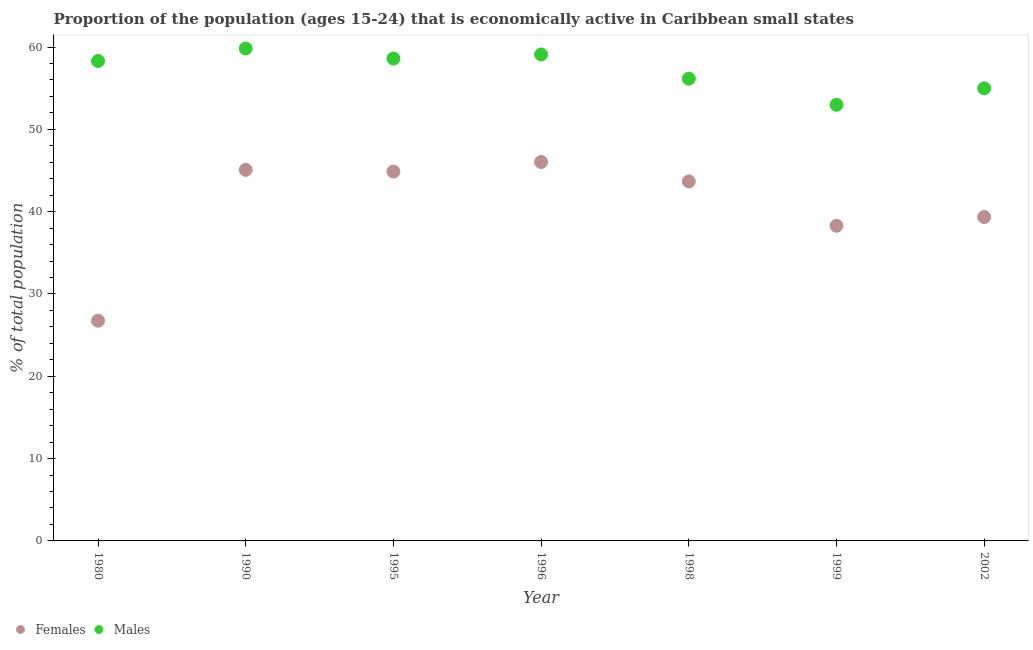What is the percentage of economically active female population in 2002?
Make the answer very short. 39.35. Across all years, what is the maximum percentage of economically active female population?
Offer a very short reply. 46.04. Across all years, what is the minimum percentage of economically active male population?
Give a very brief answer. 52.98. In which year was the percentage of economically active female population minimum?
Give a very brief answer. 1980. What is the total percentage of economically active male population in the graph?
Your response must be concise. 399.94. What is the difference between the percentage of economically active male population in 1980 and that in 1990?
Your answer should be compact. -1.52. What is the difference between the percentage of economically active male population in 2002 and the percentage of economically active female population in 1995?
Provide a short and direct response. 10.11. What is the average percentage of economically active female population per year?
Your answer should be very brief. 40.58. In the year 1998, what is the difference between the percentage of economically active male population and percentage of economically active female population?
Ensure brevity in your answer.  12.48. What is the ratio of the percentage of economically active female population in 1999 to that in 2002?
Provide a short and direct response. 0.97. Is the difference between the percentage of economically active male population in 1995 and 1998 greater than the difference between the percentage of economically active female population in 1995 and 1998?
Provide a succinct answer. Yes. What is the difference between the highest and the second highest percentage of economically active female population?
Your response must be concise. 0.96. What is the difference between the highest and the lowest percentage of economically active male population?
Ensure brevity in your answer.  6.84. Is the percentage of economically active male population strictly less than the percentage of economically active female population over the years?
Offer a very short reply. No. How many years are there in the graph?
Make the answer very short. 7. Are the values on the major ticks of Y-axis written in scientific E-notation?
Provide a short and direct response. No. Does the graph contain grids?
Give a very brief answer. No. What is the title of the graph?
Give a very brief answer. Proportion of the population (ages 15-24) that is economically active in Caribbean small states. What is the label or title of the Y-axis?
Ensure brevity in your answer.  % of total population. What is the % of total population of Females in 1980?
Ensure brevity in your answer.  26.76. What is the % of total population in Males in 1980?
Your answer should be compact. 58.31. What is the % of total population of Females in 1990?
Your answer should be compact. 45.08. What is the % of total population in Males in 1990?
Your answer should be compact. 59.82. What is the % of total population in Females in 1995?
Offer a very short reply. 44.87. What is the % of total population in Males in 1995?
Make the answer very short. 58.6. What is the % of total population in Females in 1996?
Ensure brevity in your answer.  46.04. What is the % of total population in Males in 1996?
Make the answer very short. 59.1. What is the % of total population in Females in 1998?
Provide a short and direct response. 43.68. What is the % of total population in Males in 1998?
Offer a very short reply. 56.16. What is the % of total population in Females in 1999?
Your answer should be very brief. 38.28. What is the % of total population in Males in 1999?
Your response must be concise. 52.98. What is the % of total population in Females in 2002?
Give a very brief answer. 39.35. What is the % of total population of Males in 2002?
Provide a succinct answer. 54.98. Across all years, what is the maximum % of total population in Females?
Provide a short and direct response. 46.04. Across all years, what is the maximum % of total population of Males?
Ensure brevity in your answer.  59.82. Across all years, what is the minimum % of total population in Females?
Your answer should be compact. 26.76. Across all years, what is the minimum % of total population of Males?
Give a very brief answer. 52.98. What is the total % of total population in Females in the graph?
Provide a short and direct response. 284.05. What is the total % of total population of Males in the graph?
Give a very brief answer. 399.94. What is the difference between the % of total population of Females in 1980 and that in 1990?
Give a very brief answer. -18.32. What is the difference between the % of total population in Males in 1980 and that in 1990?
Keep it short and to the point. -1.52. What is the difference between the % of total population in Females in 1980 and that in 1995?
Your answer should be compact. -18.12. What is the difference between the % of total population in Males in 1980 and that in 1995?
Provide a succinct answer. -0.29. What is the difference between the % of total population of Females in 1980 and that in 1996?
Your answer should be compact. -19.28. What is the difference between the % of total population of Males in 1980 and that in 1996?
Offer a terse response. -0.79. What is the difference between the % of total population of Females in 1980 and that in 1998?
Your answer should be very brief. -16.92. What is the difference between the % of total population in Males in 1980 and that in 1998?
Offer a very short reply. 2.15. What is the difference between the % of total population of Females in 1980 and that in 1999?
Provide a succinct answer. -11.53. What is the difference between the % of total population in Males in 1980 and that in 1999?
Give a very brief answer. 5.33. What is the difference between the % of total population in Females in 1980 and that in 2002?
Your response must be concise. -12.59. What is the difference between the % of total population in Males in 1980 and that in 2002?
Keep it short and to the point. 3.32. What is the difference between the % of total population in Females in 1990 and that in 1995?
Your answer should be very brief. 0.21. What is the difference between the % of total population of Males in 1990 and that in 1995?
Keep it short and to the point. 1.22. What is the difference between the % of total population of Females in 1990 and that in 1996?
Your answer should be very brief. -0.96. What is the difference between the % of total population in Males in 1990 and that in 1996?
Offer a terse response. 0.72. What is the difference between the % of total population of Females in 1990 and that in 1998?
Ensure brevity in your answer.  1.4. What is the difference between the % of total population of Males in 1990 and that in 1998?
Keep it short and to the point. 3.67. What is the difference between the % of total population of Females in 1990 and that in 1999?
Provide a short and direct response. 6.8. What is the difference between the % of total population of Males in 1990 and that in 1999?
Your response must be concise. 6.84. What is the difference between the % of total population in Females in 1990 and that in 2002?
Offer a very short reply. 5.73. What is the difference between the % of total population in Males in 1990 and that in 2002?
Provide a succinct answer. 4.84. What is the difference between the % of total population in Females in 1995 and that in 1996?
Keep it short and to the point. -1.16. What is the difference between the % of total population of Males in 1995 and that in 1996?
Your answer should be very brief. -0.5. What is the difference between the % of total population of Females in 1995 and that in 1998?
Keep it short and to the point. 1.2. What is the difference between the % of total population of Males in 1995 and that in 1998?
Provide a short and direct response. 2.44. What is the difference between the % of total population in Females in 1995 and that in 1999?
Ensure brevity in your answer.  6.59. What is the difference between the % of total population of Males in 1995 and that in 1999?
Offer a very short reply. 5.62. What is the difference between the % of total population in Females in 1995 and that in 2002?
Make the answer very short. 5.53. What is the difference between the % of total population of Males in 1995 and that in 2002?
Offer a terse response. 3.62. What is the difference between the % of total population of Females in 1996 and that in 1998?
Ensure brevity in your answer.  2.36. What is the difference between the % of total population in Males in 1996 and that in 1998?
Your answer should be very brief. 2.94. What is the difference between the % of total population in Females in 1996 and that in 1999?
Ensure brevity in your answer.  7.75. What is the difference between the % of total population of Males in 1996 and that in 1999?
Provide a succinct answer. 6.12. What is the difference between the % of total population of Females in 1996 and that in 2002?
Ensure brevity in your answer.  6.69. What is the difference between the % of total population in Males in 1996 and that in 2002?
Provide a short and direct response. 4.12. What is the difference between the % of total population in Females in 1998 and that in 1999?
Your response must be concise. 5.39. What is the difference between the % of total population of Males in 1998 and that in 1999?
Your response must be concise. 3.18. What is the difference between the % of total population in Females in 1998 and that in 2002?
Keep it short and to the point. 4.33. What is the difference between the % of total population in Males in 1998 and that in 2002?
Give a very brief answer. 1.17. What is the difference between the % of total population in Females in 1999 and that in 2002?
Make the answer very short. -1.06. What is the difference between the % of total population of Males in 1999 and that in 2002?
Your answer should be compact. -2. What is the difference between the % of total population of Females in 1980 and the % of total population of Males in 1990?
Your response must be concise. -33.07. What is the difference between the % of total population in Females in 1980 and the % of total population in Males in 1995?
Provide a short and direct response. -31.84. What is the difference between the % of total population in Females in 1980 and the % of total population in Males in 1996?
Give a very brief answer. -32.34. What is the difference between the % of total population in Females in 1980 and the % of total population in Males in 1998?
Give a very brief answer. -29.4. What is the difference between the % of total population of Females in 1980 and the % of total population of Males in 1999?
Ensure brevity in your answer.  -26.22. What is the difference between the % of total population in Females in 1980 and the % of total population in Males in 2002?
Make the answer very short. -28.23. What is the difference between the % of total population in Females in 1990 and the % of total population in Males in 1995?
Your answer should be very brief. -13.52. What is the difference between the % of total population of Females in 1990 and the % of total population of Males in 1996?
Keep it short and to the point. -14.02. What is the difference between the % of total population of Females in 1990 and the % of total population of Males in 1998?
Offer a terse response. -11.08. What is the difference between the % of total population of Females in 1990 and the % of total population of Males in 1999?
Provide a short and direct response. -7.9. What is the difference between the % of total population in Females in 1990 and the % of total population in Males in 2002?
Offer a terse response. -9.9. What is the difference between the % of total population in Females in 1995 and the % of total population in Males in 1996?
Offer a terse response. -14.23. What is the difference between the % of total population in Females in 1995 and the % of total population in Males in 1998?
Offer a terse response. -11.28. What is the difference between the % of total population in Females in 1995 and the % of total population in Males in 1999?
Make the answer very short. -8.11. What is the difference between the % of total population of Females in 1995 and the % of total population of Males in 2002?
Give a very brief answer. -10.11. What is the difference between the % of total population in Females in 1996 and the % of total population in Males in 1998?
Make the answer very short. -10.12. What is the difference between the % of total population in Females in 1996 and the % of total population in Males in 1999?
Offer a terse response. -6.94. What is the difference between the % of total population of Females in 1996 and the % of total population of Males in 2002?
Provide a short and direct response. -8.95. What is the difference between the % of total population in Females in 1998 and the % of total population in Males in 1999?
Your answer should be compact. -9.3. What is the difference between the % of total population in Females in 1998 and the % of total population in Males in 2002?
Offer a very short reply. -11.31. What is the difference between the % of total population in Females in 1999 and the % of total population in Males in 2002?
Give a very brief answer. -16.7. What is the average % of total population of Females per year?
Your response must be concise. 40.58. What is the average % of total population in Males per year?
Your response must be concise. 57.13. In the year 1980, what is the difference between the % of total population in Females and % of total population in Males?
Make the answer very short. -31.55. In the year 1990, what is the difference between the % of total population of Females and % of total population of Males?
Offer a terse response. -14.74. In the year 1995, what is the difference between the % of total population in Females and % of total population in Males?
Your response must be concise. -13.73. In the year 1996, what is the difference between the % of total population of Females and % of total population of Males?
Your answer should be compact. -13.06. In the year 1998, what is the difference between the % of total population of Females and % of total population of Males?
Offer a terse response. -12.48. In the year 1999, what is the difference between the % of total population of Females and % of total population of Males?
Offer a terse response. -14.7. In the year 2002, what is the difference between the % of total population in Females and % of total population in Males?
Your answer should be very brief. -15.64. What is the ratio of the % of total population of Females in 1980 to that in 1990?
Offer a very short reply. 0.59. What is the ratio of the % of total population of Males in 1980 to that in 1990?
Ensure brevity in your answer.  0.97. What is the ratio of the % of total population of Females in 1980 to that in 1995?
Give a very brief answer. 0.6. What is the ratio of the % of total population of Males in 1980 to that in 1995?
Give a very brief answer. 0.99. What is the ratio of the % of total population of Females in 1980 to that in 1996?
Keep it short and to the point. 0.58. What is the ratio of the % of total population in Males in 1980 to that in 1996?
Your answer should be compact. 0.99. What is the ratio of the % of total population in Females in 1980 to that in 1998?
Offer a very short reply. 0.61. What is the ratio of the % of total population in Males in 1980 to that in 1998?
Ensure brevity in your answer.  1.04. What is the ratio of the % of total population in Females in 1980 to that in 1999?
Your answer should be compact. 0.7. What is the ratio of the % of total population of Males in 1980 to that in 1999?
Offer a very short reply. 1.1. What is the ratio of the % of total population in Females in 1980 to that in 2002?
Ensure brevity in your answer.  0.68. What is the ratio of the % of total population of Males in 1980 to that in 2002?
Offer a very short reply. 1.06. What is the ratio of the % of total population in Females in 1990 to that in 1995?
Provide a short and direct response. 1. What is the ratio of the % of total population of Males in 1990 to that in 1995?
Your answer should be very brief. 1.02. What is the ratio of the % of total population in Females in 1990 to that in 1996?
Your response must be concise. 0.98. What is the ratio of the % of total population of Males in 1990 to that in 1996?
Offer a terse response. 1.01. What is the ratio of the % of total population in Females in 1990 to that in 1998?
Your answer should be compact. 1.03. What is the ratio of the % of total population of Males in 1990 to that in 1998?
Your answer should be compact. 1.07. What is the ratio of the % of total population of Females in 1990 to that in 1999?
Keep it short and to the point. 1.18. What is the ratio of the % of total population in Males in 1990 to that in 1999?
Offer a very short reply. 1.13. What is the ratio of the % of total population of Females in 1990 to that in 2002?
Ensure brevity in your answer.  1.15. What is the ratio of the % of total population of Males in 1990 to that in 2002?
Your answer should be very brief. 1.09. What is the ratio of the % of total population in Females in 1995 to that in 1996?
Your answer should be compact. 0.97. What is the ratio of the % of total population in Females in 1995 to that in 1998?
Make the answer very short. 1.03. What is the ratio of the % of total population in Males in 1995 to that in 1998?
Your response must be concise. 1.04. What is the ratio of the % of total population in Females in 1995 to that in 1999?
Keep it short and to the point. 1.17. What is the ratio of the % of total population in Males in 1995 to that in 1999?
Keep it short and to the point. 1.11. What is the ratio of the % of total population of Females in 1995 to that in 2002?
Your answer should be compact. 1.14. What is the ratio of the % of total population in Males in 1995 to that in 2002?
Provide a short and direct response. 1.07. What is the ratio of the % of total population in Females in 1996 to that in 1998?
Your answer should be very brief. 1.05. What is the ratio of the % of total population of Males in 1996 to that in 1998?
Your answer should be compact. 1.05. What is the ratio of the % of total population of Females in 1996 to that in 1999?
Offer a very short reply. 1.2. What is the ratio of the % of total population in Males in 1996 to that in 1999?
Provide a succinct answer. 1.12. What is the ratio of the % of total population in Females in 1996 to that in 2002?
Your response must be concise. 1.17. What is the ratio of the % of total population in Males in 1996 to that in 2002?
Your response must be concise. 1.07. What is the ratio of the % of total population of Females in 1998 to that in 1999?
Provide a succinct answer. 1.14. What is the ratio of the % of total population of Males in 1998 to that in 1999?
Provide a short and direct response. 1.06. What is the ratio of the % of total population in Females in 1998 to that in 2002?
Your response must be concise. 1.11. What is the ratio of the % of total population in Males in 1998 to that in 2002?
Offer a very short reply. 1.02. What is the ratio of the % of total population of Males in 1999 to that in 2002?
Give a very brief answer. 0.96. What is the difference between the highest and the second highest % of total population of Females?
Your answer should be very brief. 0.96. What is the difference between the highest and the second highest % of total population in Males?
Give a very brief answer. 0.72. What is the difference between the highest and the lowest % of total population in Females?
Keep it short and to the point. 19.28. What is the difference between the highest and the lowest % of total population of Males?
Provide a succinct answer. 6.84. 